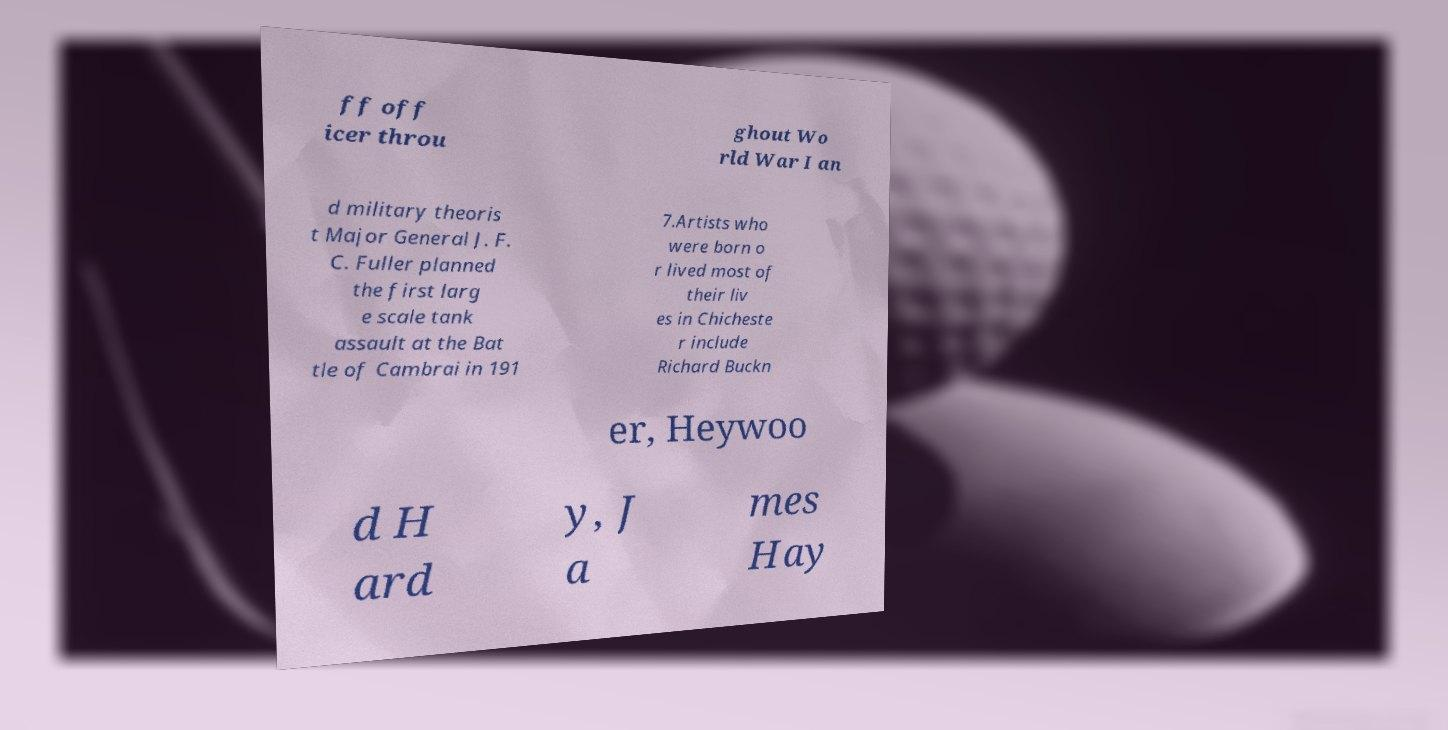Can you read and provide the text displayed in the image?This photo seems to have some interesting text. Can you extract and type it out for me? ff off icer throu ghout Wo rld War I an d military theoris t Major General J. F. C. Fuller planned the first larg e scale tank assault at the Bat tle of Cambrai in 191 7.Artists who were born o r lived most of their liv es in Chicheste r include Richard Buckn er, Heywoo d H ard y, J a mes Hay 